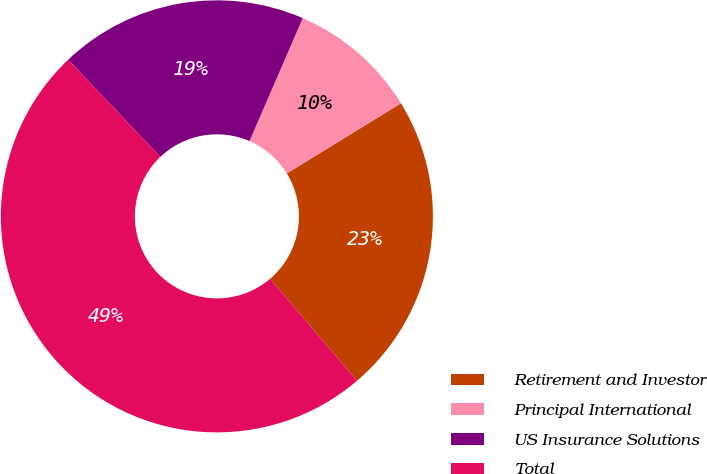<chart> <loc_0><loc_0><loc_500><loc_500><pie_chart><fcel>Retirement and Investor<fcel>Principal International<fcel>US Insurance Solutions<fcel>Total<nl><fcel>22.54%<fcel>9.73%<fcel>18.6%<fcel>49.14%<nl></chart> 